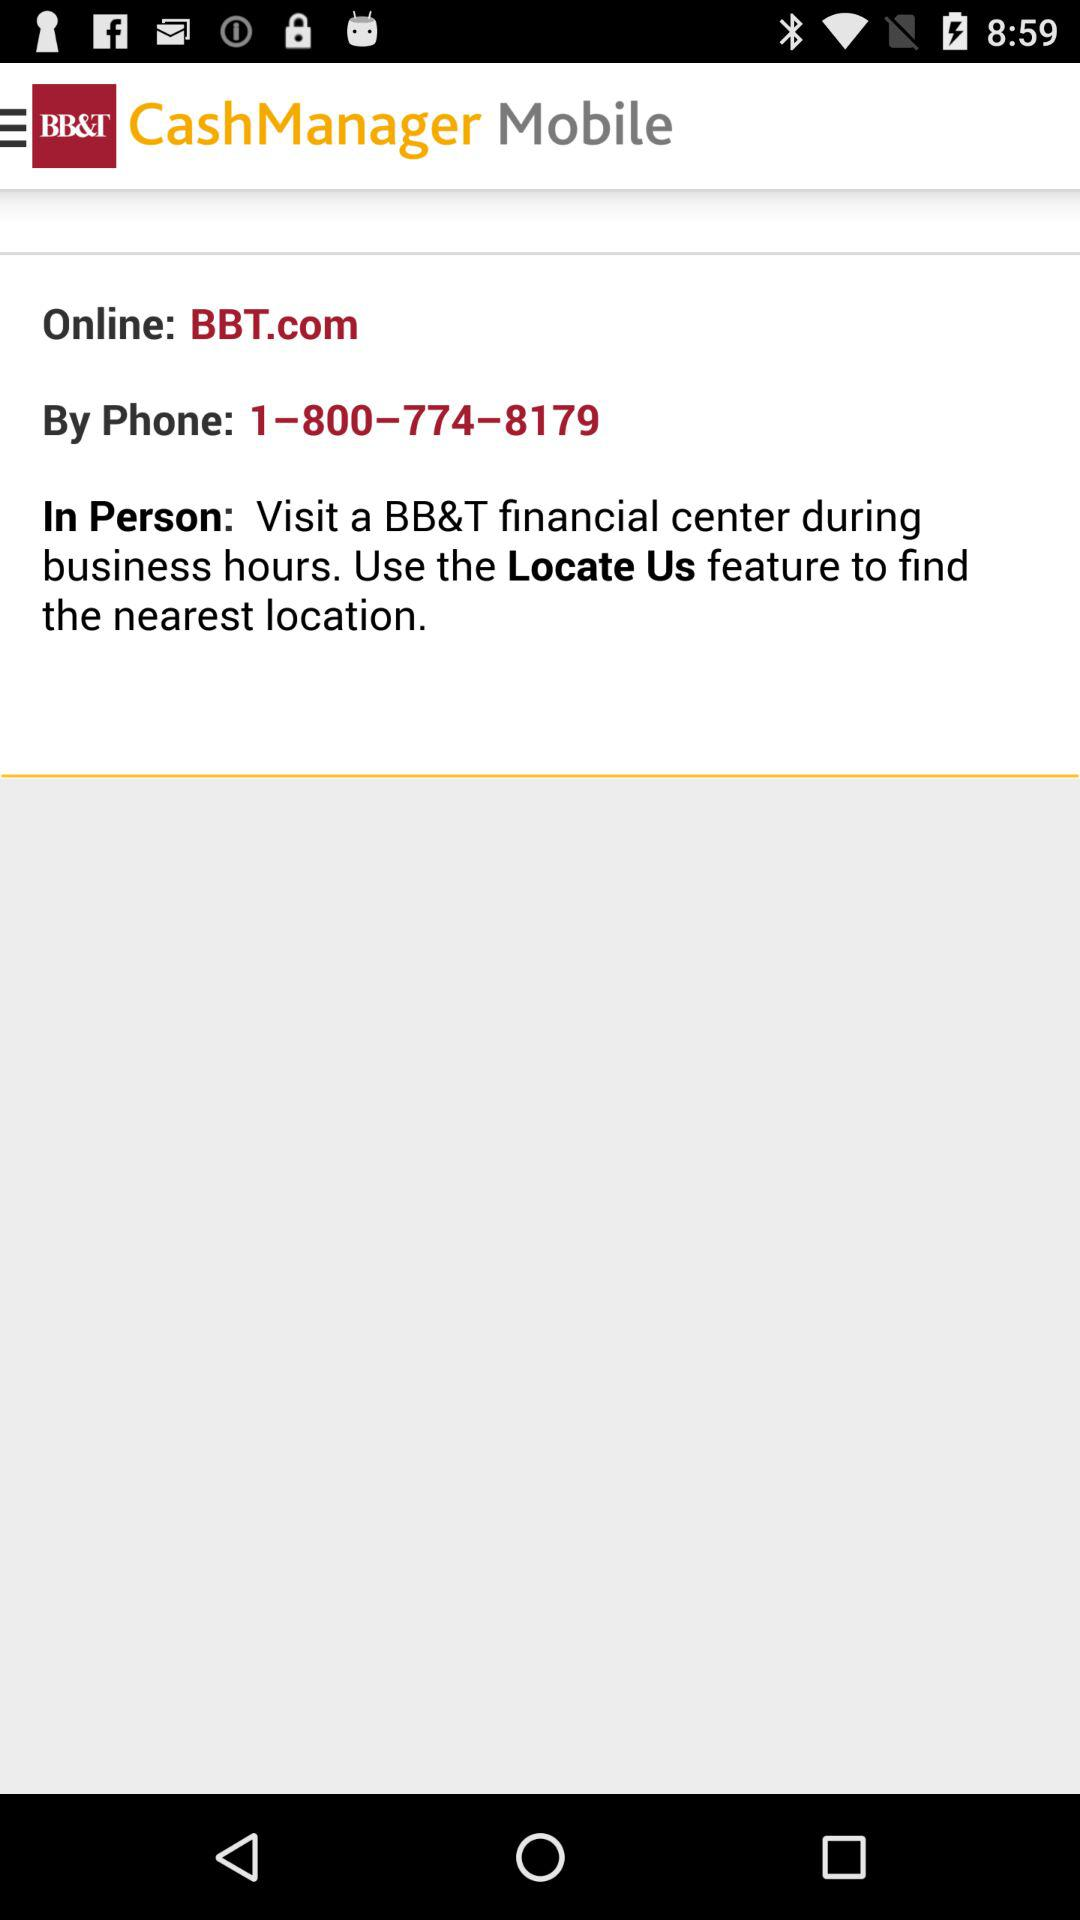What feature is used to find the nearest location? The feature used to find the nearest location is "Locate Us". 